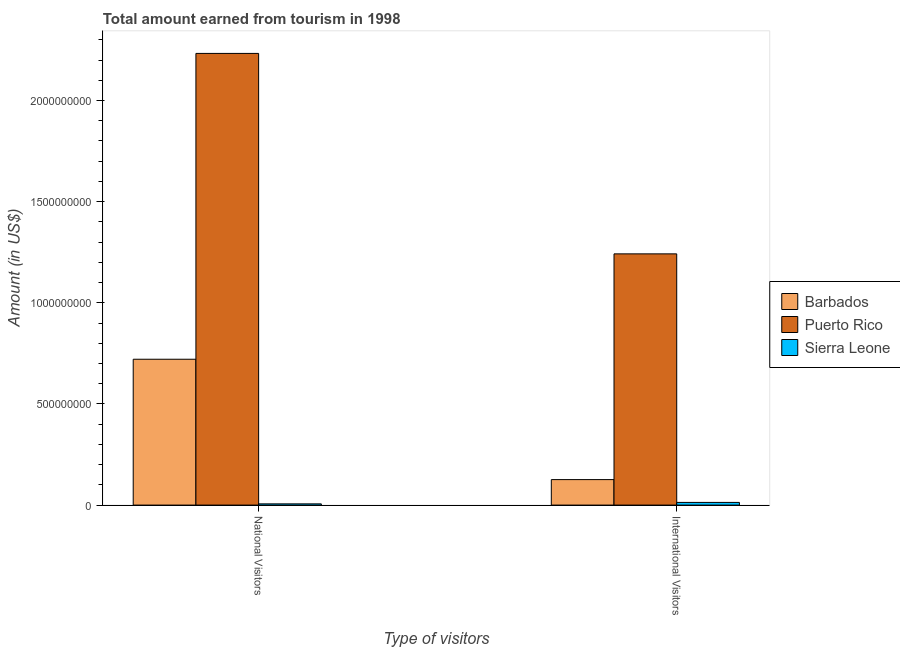How many groups of bars are there?
Provide a short and direct response. 2. Are the number of bars on each tick of the X-axis equal?
Provide a succinct answer. Yes. How many bars are there on the 1st tick from the right?
Keep it short and to the point. 3. What is the label of the 2nd group of bars from the left?
Offer a very short reply. International Visitors. What is the amount earned from international visitors in Barbados?
Provide a succinct answer. 1.26e+08. Across all countries, what is the maximum amount earned from international visitors?
Your answer should be very brief. 1.24e+09. Across all countries, what is the minimum amount earned from national visitors?
Your answer should be very brief. 6.00e+06. In which country was the amount earned from national visitors maximum?
Your answer should be very brief. Puerto Rico. In which country was the amount earned from national visitors minimum?
Provide a short and direct response. Sierra Leone. What is the total amount earned from national visitors in the graph?
Ensure brevity in your answer.  2.96e+09. What is the difference between the amount earned from international visitors in Puerto Rico and that in Barbados?
Provide a succinct answer. 1.12e+09. What is the difference between the amount earned from international visitors in Sierra Leone and the amount earned from national visitors in Puerto Rico?
Your response must be concise. -2.22e+09. What is the average amount earned from international visitors per country?
Make the answer very short. 4.60e+08. What is the difference between the amount earned from international visitors and amount earned from national visitors in Puerto Rico?
Make the answer very short. -9.91e+08. What is the ratio of the amount earned from international visitors in Puerto Rico to that in Barbados?
Your answer should be very brief. 9.86. Is the amount earned from international visitors in Barbados less than that in Puerto Rico?
Your answer should be very brief. Yes. In how many countries, is the amount earned from international visitors greater than the average amount earned from international visitors taken over all countries?
Provide a short and direct response. 1. What does the 1st bar from the left in International Visitors represents?
Provide a short and direct response. Barbados. What does the 3rd bar from the right in National Visitors represents?
Give a very brief answer. Barbados. Where does the legend appear in the graph?
Provide a short and direct response. Center right. How are the legend labels stacked?
Make the answer very short. Vertical. What is the title of the graph?
Offer a very short reply. Total amount earned from tourism in 1998. What is the label or title of the X-axis?
Your response must be concise. Type of visitors. What is the label or title of the Y-axis?
Give a very brief answer. Amount (in US$). What is the Amount (in US$) in Barbados in National Visitors?
Provide a succinct answer. 7.21e+08. What is the Amount (in US$) of Puerto Rico in National Visitors?
Keep it short and to the point. 2.23e+09. What is the Amount (in US$) of Barbados in International Visitors?
Your response must be concise. 1.26e+08. What is the Amount (in US$) in Puerto Rico in International Visitors?
Give a very brief answer. 1.24e+09. What is the Amount (in US$) in Sierra Leone in International Visitors?
Keep it short and to the point. 1.32e+07. Across all Type of visitors, what is the maximum Amount (in US$) in Barbados?
Your response must be concise. 7.21e+08. Across all Type of visitors, what is the maximum Amount (in US$) in Puerto Rico?
Keep it short and to the point. 2.23e+09. Across all Type of visitors, what is the maximum Amount (in US$) in Sierra Leone?
Provide a short and direct response. 1.32e+07. Across all Type of visitors, what is the minimum Amount (in US$) in Barbados?
Offer a terse response. 1.26e+08. Across all Type of visitors, what is the minimum Amount (in US$) in Puerto Rico?
Offer a very short reply. 1.24e+09. Across all Type of visitors, what is the minimum Amount (in US$) in Sierra Leone?
Your answer should be compact. 6.00e+06. What is the total Amount (in US$) of Barbados in the graph?
Offer a very short reply. 8.47e+08. What is the total Amount (in US$) in Puerto Rico in the graph?
Your answer should be compact. 3.48e+09. What is the total Amount (in US$) in Sierra Leone in the graph?
Offer a very short reply. 1.92e+07. What is the difference between the Amount (in US$) of Barbados in National Visitors and that in International Visitors?
Make the answer very short. 5.95e+08. What is the difference between the Amount (in US$) of Puerto Rico in National Visitors and that in International Visitors?
Offer a very short reply. 9.91e+08. What is the difference between the Amount (in US$) in Sierra Leone in National Visitors and that in International Visitors?
Ensure brevity in your answer.  -7.20e+06. What is the difference between the Amount (in US$) of Barbados in National Visitors and the Amount (in US$) of Puerto Rico in International Visitors?
Give a very brief answer. -5.21e+08. What is the difference between the Amount (in US$) of Barbados in National Visitors and the Amount (in US$) of Sierra Leone in International Visitors?
Your answer should be compact. 7.08e+08. What is the difference between the Amount (in US$) in Puerto Rico in National Visitors and the Amount (in US$) in Sierra Leone in International Visitors?
Provide a succinct answer. 2.22e+09. What is the average Amount (in US$) of Barbados per Type of visitors?
Offer a terse response. 4.24e+08. What is the average Amount (in US$) of Puerto Rico per Type of visitors?
Ensure brevity in your answer.  1.74e+09. What is the average Amount (in US$) of Sierra Leone per Type of visitors?
Your response must be concise. 9.60e+06. What is the difference between the Amount (in US$) of Barbados and Amount (in US$) of Puerto Rico in National Visitors?
Provide a short and direct response. -1.51e+09. What is the difference between the Amount (in US$) of Barbados and Amount (in US$) of Sierra Leone in National Visitors?
Offer a terse response. 7.15e+08. What is the difference between the Amount (in US$) in Puerto Rico and Amount (in US$) in Sierra Leone in National Visitors?
Your answer should be very brief. 2.23e+09. What is the difference between the Amount (in US$) in Barbados and Amount (in US$) in Puerto Rico in International Visitors?
Keep it short and to the point. -1.12e+09. What is the difference between the Amount (in US$) in Barbados and Amount (in US$) in Sierra Leone in International Visitors?
Make the answer very short. 1.13e+08. What is the difference between the Amount (in US$) of Puerto Rico and Amount (in US$) of Sierra Leone in International Visitors?
Ensure brevity in your answer.  1.23e+09. What is the ratio of the Amount (in US$) in Barbados in National Visitors to that in International Visitors?
Offer a very short reply. 5.72. What is the ratio of the Amount (in US$) in Puerto Rico in National Visitors to that in International Visitors?
Your answer should be compact. 1.8. What is the ratio of the Amount (in US$) in Sierra Leone in National Visitors to that in International Visitors?
Keep it short and to the point. 0.45. What is the difference between the highest and the second highest Amount (in US$) in Barbados?
Keep it short and to the point. 5.95e+08. What is the difference between the highest and the second highest Amount (in US$) in Puerto Rico?
Your answer should be compact. 9.91e+08. What is the difference between the highest and the second highest Amount (in US$) of Sierra Leone?
Your response must be concise. 7.20e+06. What is the difference between the highest and the lowest Amount (in US$) of Barbados?
Your response must be concise. 5.95e+08. What is the difference between the highest and the lowest Amount (in US$) in Puerto Rico?
Offer a very short reply. 9.91e+08. What is the difference between the highest and the lowest Amount (in US$) in Sierra Leone?
Keep it short and to the point. 7.20e+06. 